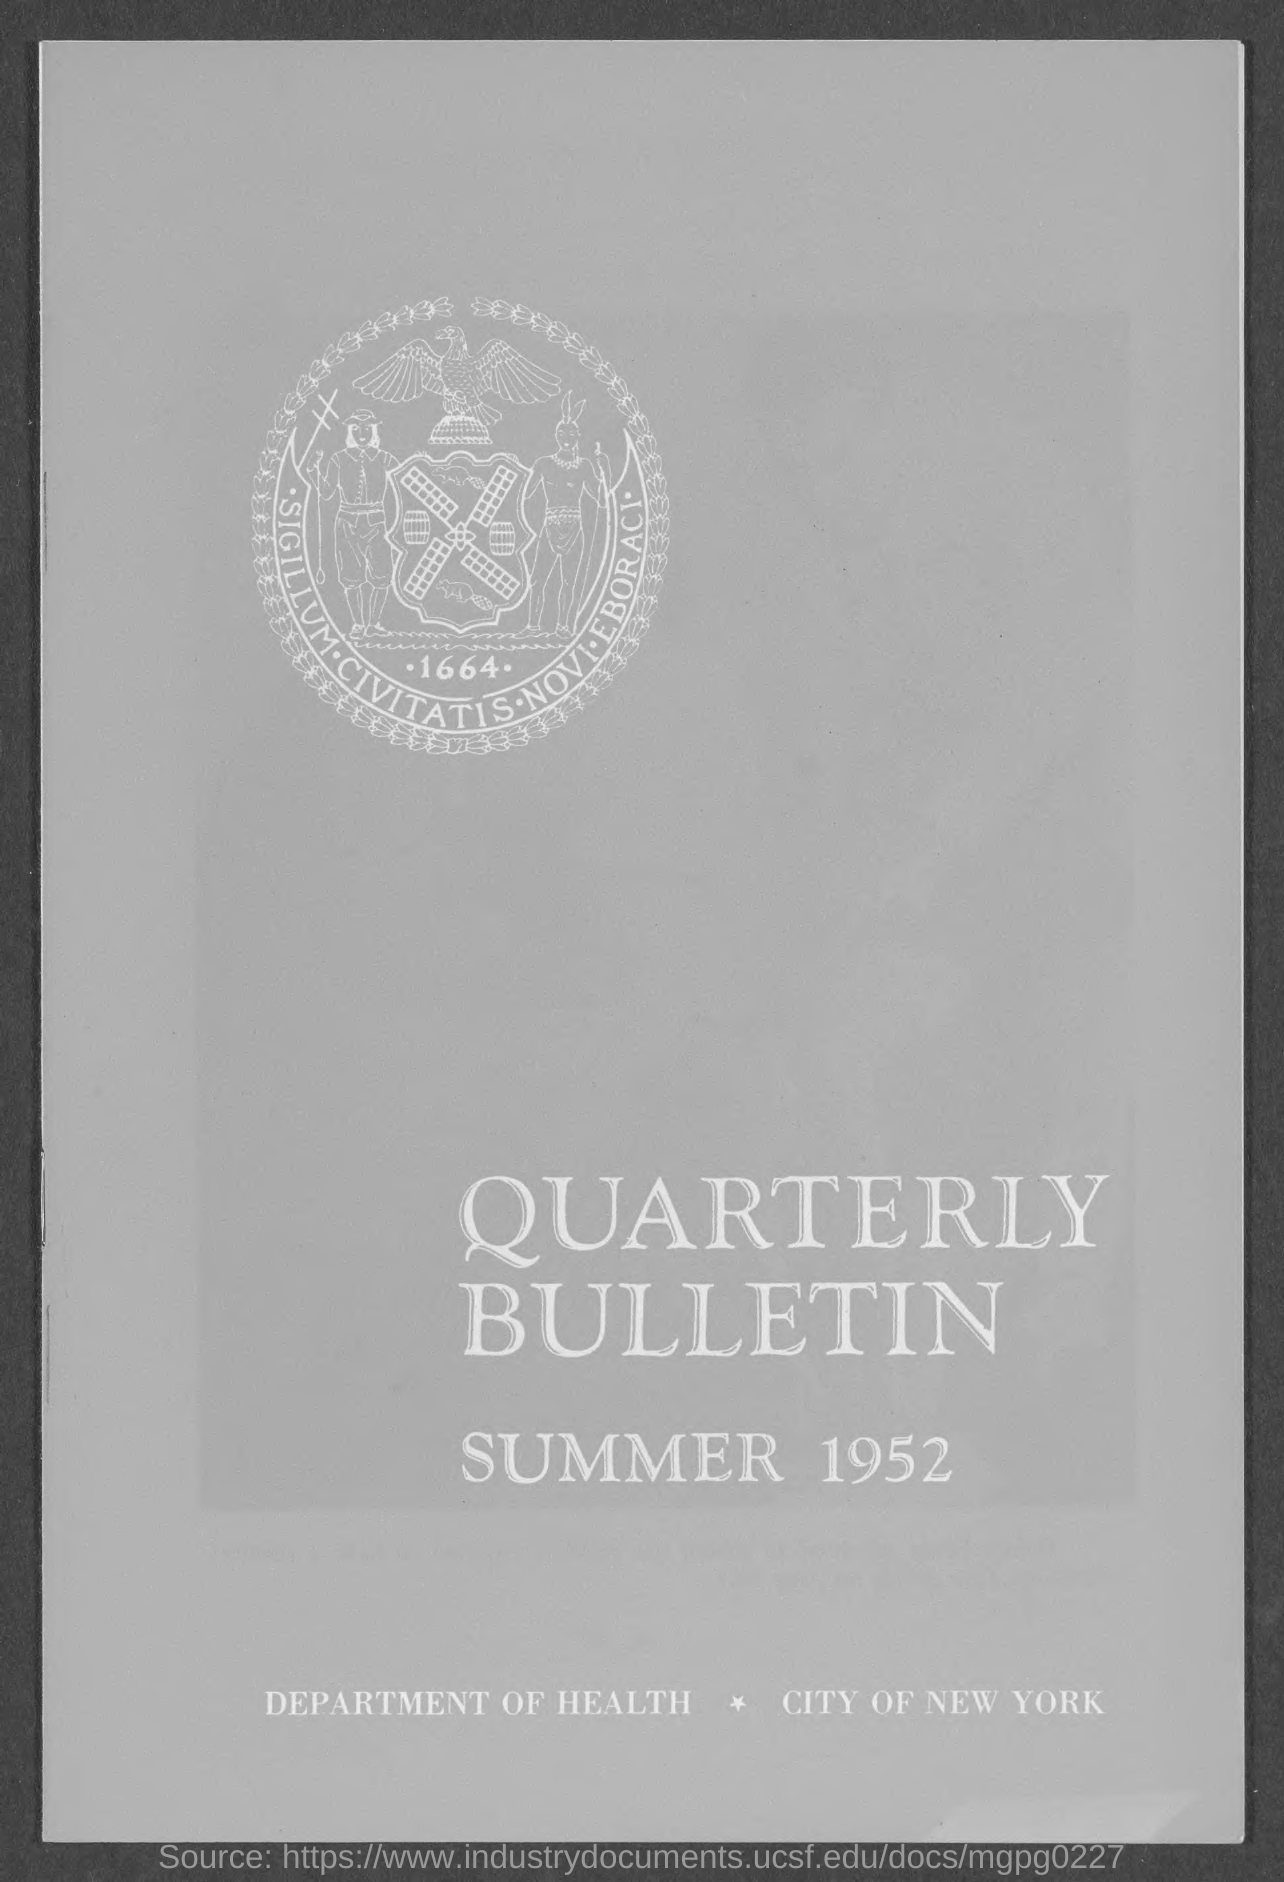Specify some key components in this picture. It is mentioned in the document that New York is a city. Please provide the title of the document, which is the Quarterly Bulletin. The year mentioned in the document is 1952. 